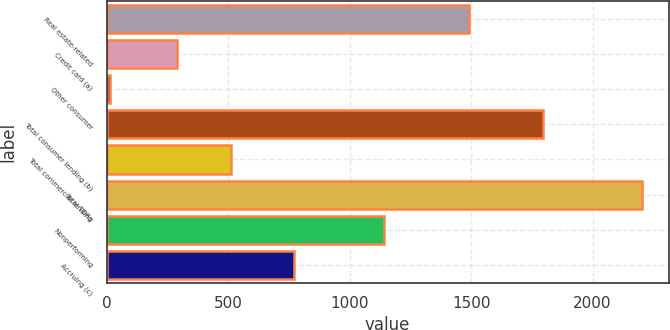Convert chart to OTSL. <chart><loc_0><loc_0><loc_500><loc_500><bar_chart><fcel>Real estate-related<fcel>Credit card (a)<fcel>Other consumer<fcel>Total consumer lending (b)<fcel>Total commercial lending<fcel>Total TDRs<fcel>Nonperforming<fcel>Accruing (c)<nl><fcel>1492<fcel>291<fcel>15<fcel>1798<fcel>509.8<fcel>2203<fcel>1141<fcel>771<nl></chart> 